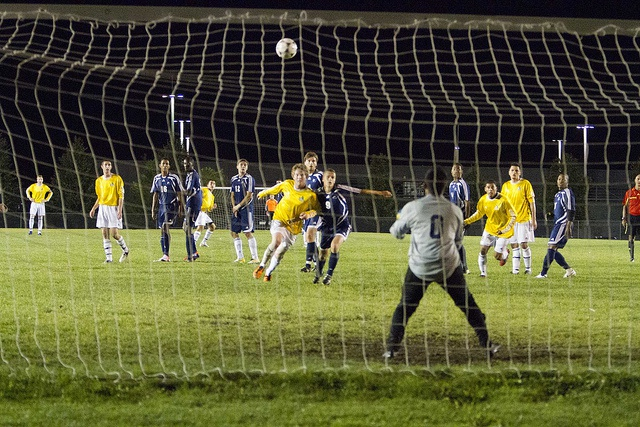Describe the objects in this image and their specific colors. I can see people in black, gray, darkgray, and darkgreen tones, people in black, tan, gray, and lightgray tones, people in black, gold, lightgray, tan, and olive tones, people in black, gold, lightgray, olive, and tan tones, and people in black, gray, tan, and navy tones in this image. 